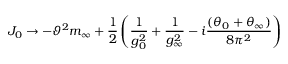<formula> <loc_0><loc_0><loc_500><loc_500>J _ { 0 } \to - \vartheta ^ { 2 } m _ { \infty } + \frac { 1 } { 2 } \left ( \frac { 1 } { g _ { 0 } ^ { 2 } } + \frac { 1 } { g _ { \infty } ^ { 2 } } - i \frac { ( \theta _ { 0 } + \theta _ { \infty } ) } { 8 \pi ^ { 2 } } \right )</formula> 